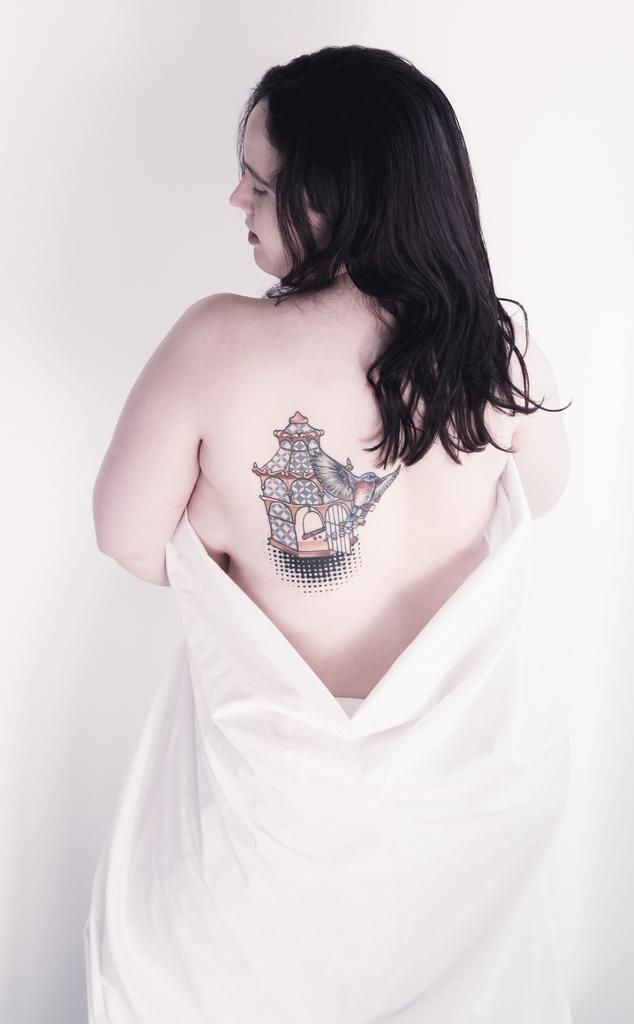How would you summarize this image in a sentence or two? In this image we can see a woman, on her back we can see a tattoo and the background is white. 